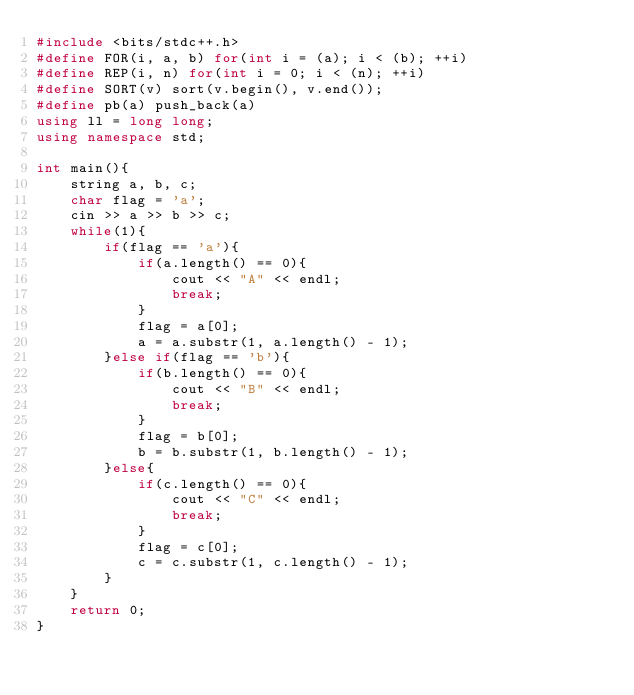Convert code to text. <code><loc_0><loc_0><loc_500><loc_500><_C++_>#include <bits/stdc++.h>
#define FOR(i, a, b) for(int i = (a); i < (b); ++i)
#define REP(i, n) for(int i = 0; i < (n); ++i)
#define SORT(v) sort(v.begin(), v.end());
#define pb(a) push_back(a)
using ll = long long;
using namespace std;

int main(){
    string a, b, c;
    char flag = 'a';
    cin >> a >> b >> c;
    while(1){
        if(flag == 'a'){
            if(a.length() == 0){
                cout << "A" << endl;
                break;
            }
            flag = a[0];
            a = a.substr(1, a.length() - 1);
        }else if(flag == 'b'){
            if(b.length() == 0){
                cout << "B" << endl;
                break;
            }
            flag = b[0];
            b = b.substr(1, b.length() - 1);
        }else{
            if(c.length() == 0){
                cout << "C" << endl;
                break;
            }
            flag = c[0];
            c = c.substr(1, c.length() - 1);
        }
    }
    return 0;
}</code> 